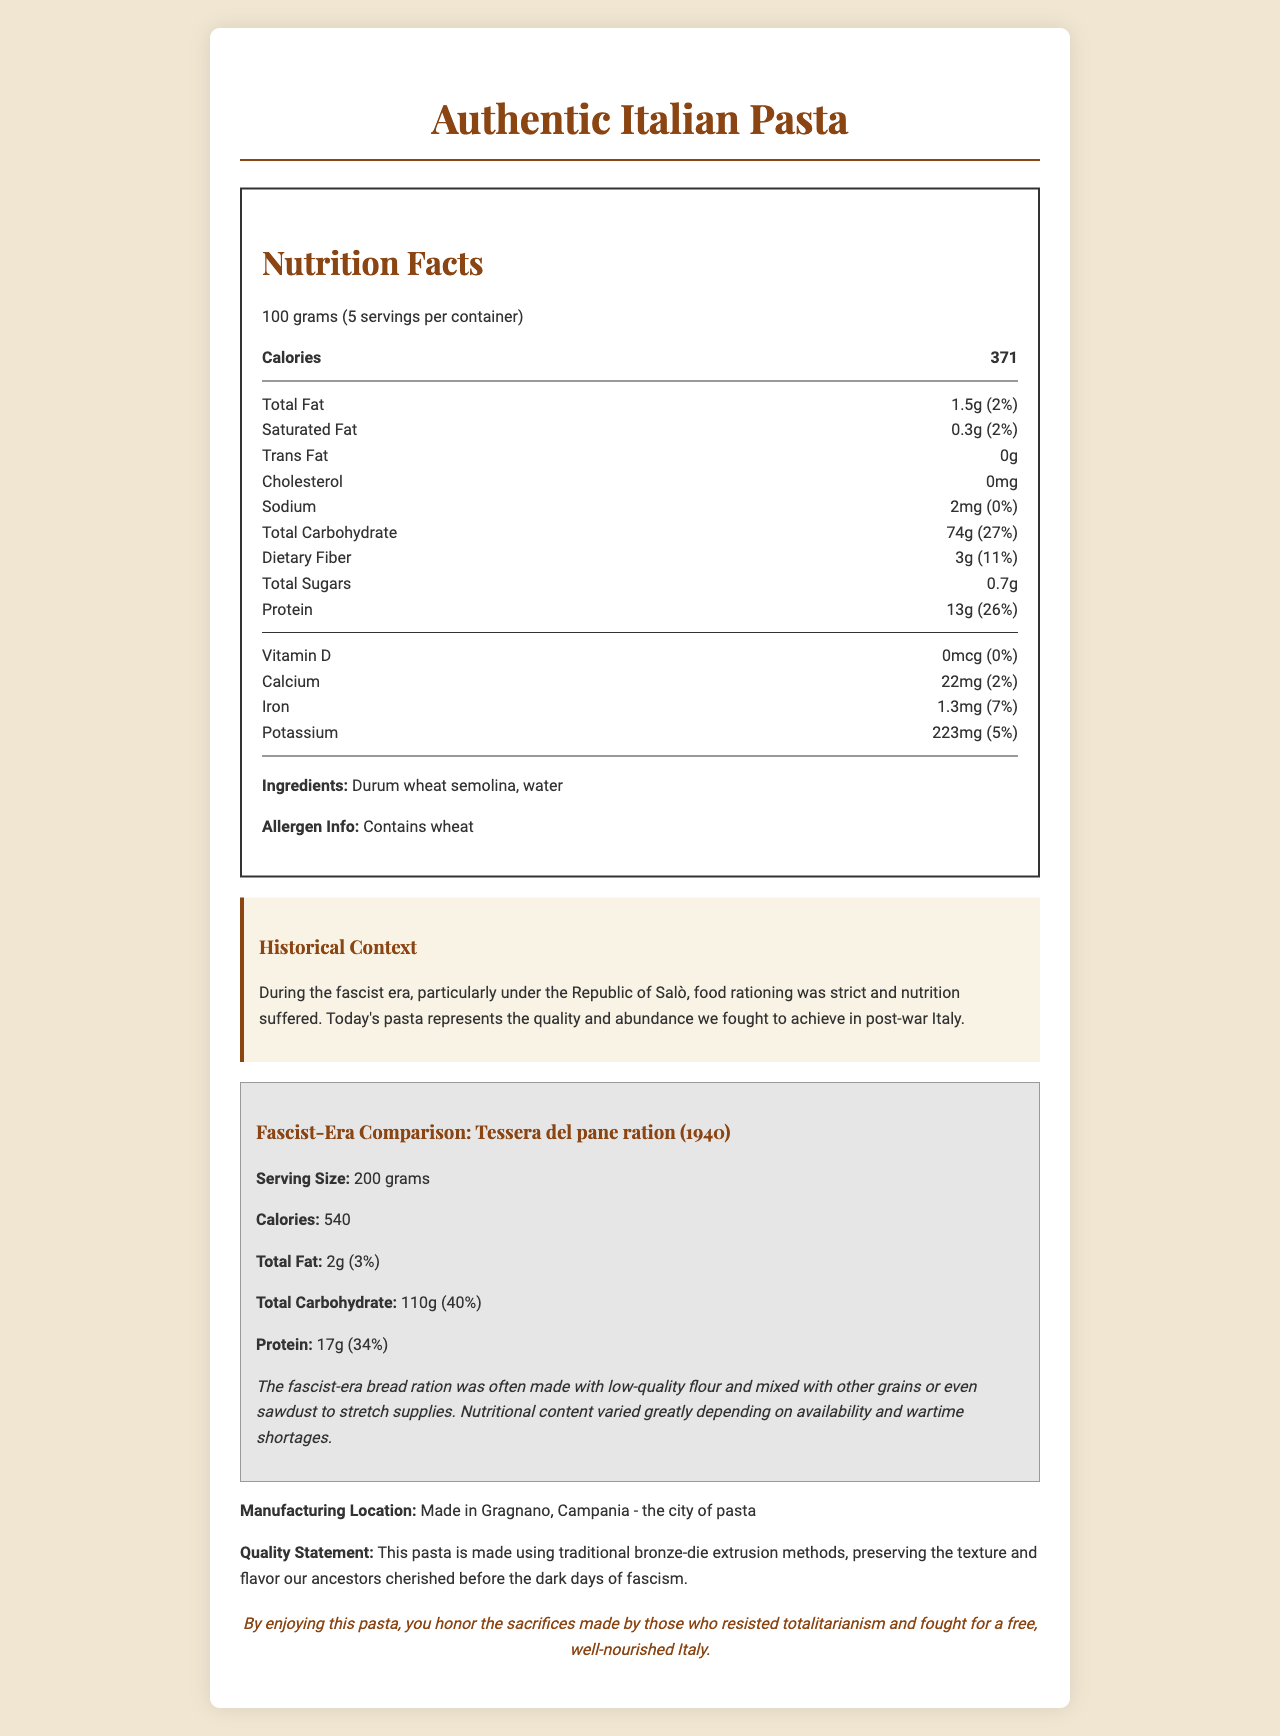what is the serving size of Authentic Italian Pasta? The serving size is listed as 100 grams in the Nutrition Facts section.
Answer: 100 grams how many calories are in one serving of Authentic Italian Pasta? The calories per serving are specified as 371 in the Nutrition Facts section.
Answer: 371 how much protein is in a 200 gram serving of Authentic Italian Pasta? There are 13 grams of protein per 100 grams serving, so for a 200 grams serving, it's 13 * 2 = 26 grams.
Answer: 26 grams what is the daily value percentage of dietary fiber in one serving of Authentic Italian Pasta? The daily value percentage of dietary fiber is listed as 11% in the Nutrition Facts section.
Answer: 11% does Authentic Italian Pasta contain any cholesterol? The cholesterol content is listed as 0 mg in the Nutrition Facts section.
Answer: No which manufacturing method is used to preserve the texture and flavor of Authentic Italian Pasta? A. Stone-milling B. Bronze-die extrusion C. Roller-milling D. Sun-drying The quality statement mentions that the pasta is made using traditional bronze-die extrusion methods.
Answer: B what is the comparison product mentioned from the fascist era? A. Tessera del pane ration B. Republic of Salò ration C. Wartime pasta ration D. Mussolini's staple product The comparison product is the "Tessera del pane ration," as mentioned in the fascist-era comparison section.
Answer: A how many calories were in a 200 gram serving of the fascist-era bread ration? A. 600 B. 540 C. 460 D. 740 The fascist-era bread ration had 540 calories for a 200 grams serving.
Answer: B does the Authentic Italian Pasta contain any added sugars? The total sugars are listed as 0.7 grams, which implies it contains naturally occurring sugars rather than added sugars.
Answer: No is the nutritional content and quality better in Authentic Italian Pasta compared to the fascist-era bread ration? The Authentic Italian Pasta has a more consistent and higher quality nutritional profile compared to the lower-quality, varied nutritional content of the fascist-era bread ration.
Answer: Yes what is the significance of the manufacturing location of Authentic Italian Pasta? The manufacturing location is specified as Gragnano, Campania, which is known as the city of pasta, implying traditional and authentic production methods.
Answer: It's made in Gragnano, Campania, the city of pasta summarize the main idea of the document. The document combines specific nutritional facts with historical comparisons to stress the increased quality and consistency in modern Italian products compared to the hardships faced during the fascist era.
Answer: The document provides detailed nutritional information about Authentic Italian Pasta, compares it with fascist-era bread rations to highlight nutritional improvements, and emphasizes the quality and historical significance of the pasta production. where is the iron content listed for the fascist-era bread ration? The document does not provide the iron content for the fascist-era bread ration.
Answer: Not listed 